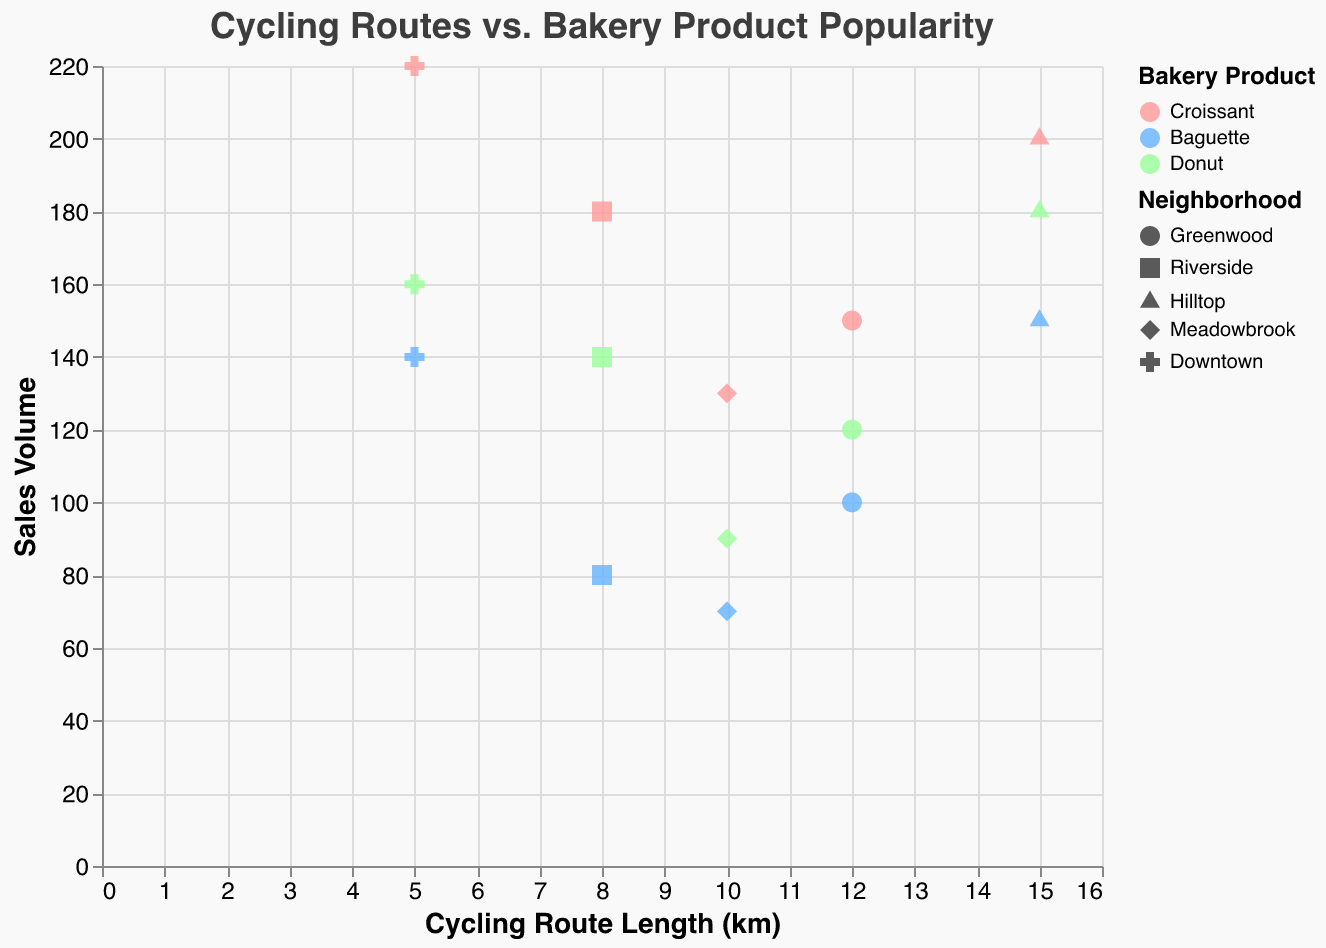What is the title of the figure? The title is prominently displayed at the top of the figure.
Answer: Cycling Routes vs. Bakery Product Popularity How many neighborhoods are displayed in the plot? There are five distinct shapes used in the figure, each representing a different neighborhood.
Answer: Five Which bakery product has the highest sales volume in Downtown? By examining the data points for Downtown (cross shapes), the highest sales volume among them is associated with the Croissant, at 220 units.
Answer: Croissant, 220 How does the sales volume of Baguettes in Greenwood compare to Hilltop? In Greenwood, the sales volume of Baguettes is 100, while in Hilltop, it is 150. Hilltop's volume is greater by 50 units.
Answer: Hilltop has 50 more sales For neighborhoods with the 8 km cycling route length, which bakery product has the highest sales volume? By checking the data points representing the 8 km cycling route (Riverside), the highest sales volume is for Croissant at 180 units.
Answer: Croissant, 180 What is the average sales volume of Donuts across all neighborhoods? Summing the sales volumes of Donuts (120, 140, 180, 90, 160), we get 690. Dividing by the number of neighborhoods (5), the average sales volume is 138.
Answer: 138 Which neighborhood has the highest sales volume of any bakery product, and what is it? Examining the highest sales volumes per neighborhood, Downtown (cross shapes) has a Croissant with 220 units, which is the highest overall.
Answer: Downtown, 220 Between the neighborhoods of Meadowbrook and Riverside, which has higher overall average sales volume for all bakery products? Calculating the total sales for Meadowbrook (130 + 70 + 90 = 290) and Riverside (180 + 80 + 140 = 400), then dividing by the number of products (3), Meadowbrook's average is 96.67, and Riverside's is 133.33.
Answer: Riverside, 133.33 Is there a correlation between the cycling route length and the sales volume of Croissants? By observing the distribution of Croissant sales across different cycling route lengths, we can see a visible trend where longer cycling routes generally correspond to higher sales volumes, indicating a positive correlation.
Answer: Positive correlation 